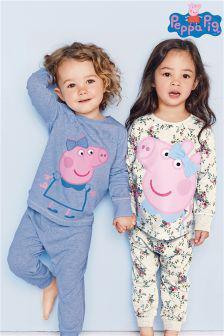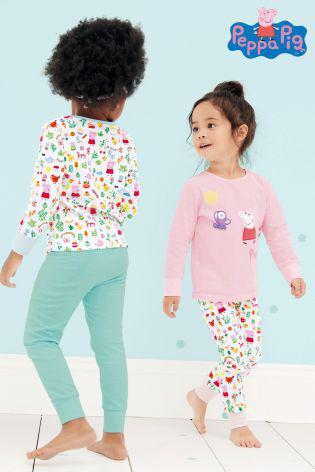The first image is the image on the left, the second image is the image on the right. Evaluate the accuracy of this statement regarding the images: "In the left image, the kids are holding each other's hands.". Is it true? Answer yes or no. Yes. 